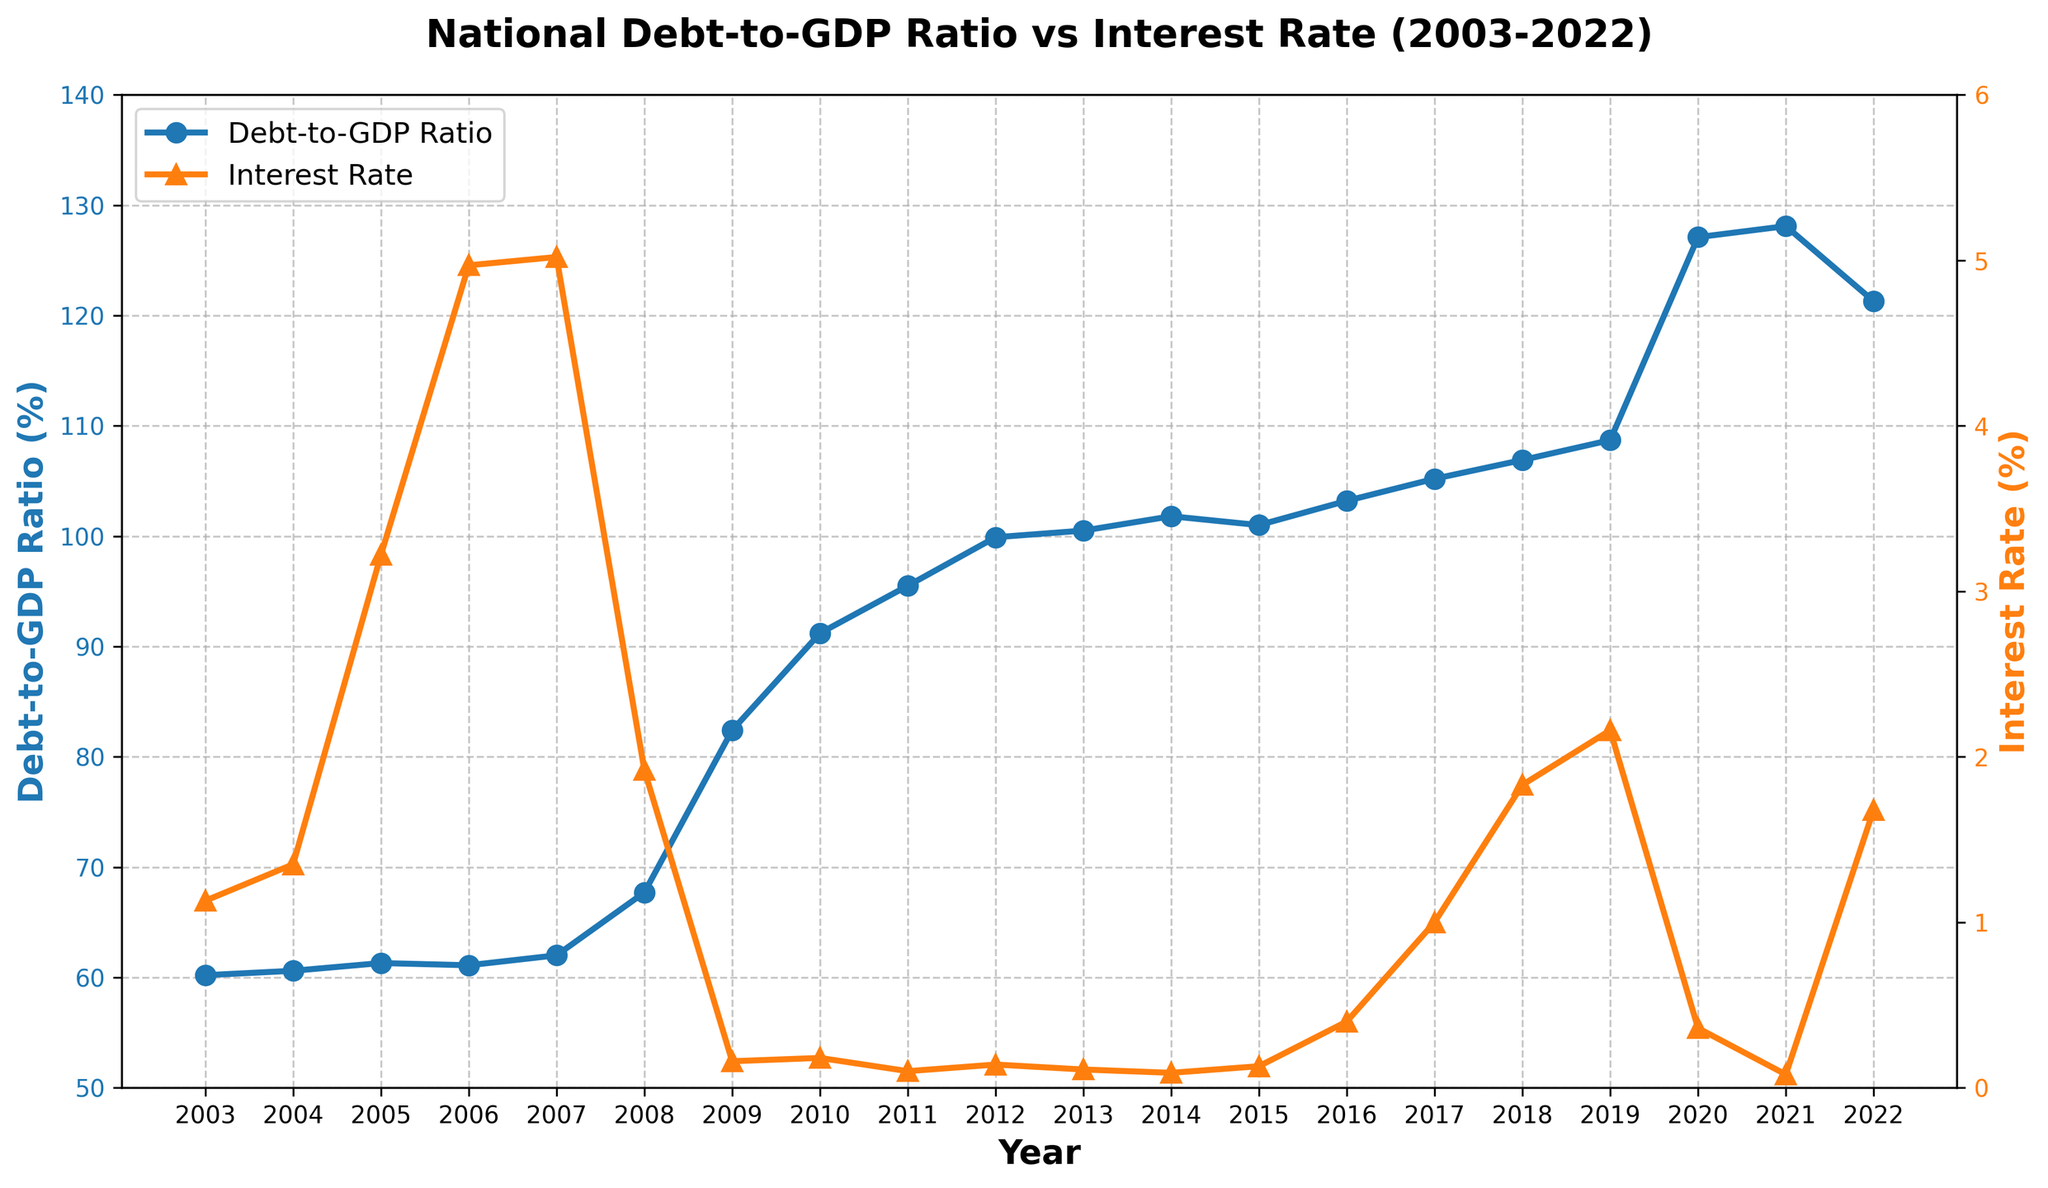What trend do we observe in the Debt-to-GDP Ratio between 2008 and 2011? To determine the trend, look at the plot line for the Debt-to-GDP Ratio during these years. In 2008, the ratio is 67.7%, and it increases to 95.5% in 2011. This shows a clear upward trend.
Answer: Upward trend What was the Interest Rate in 2013, and how does it compare to the Interest Rate in 2021? Look at the Interest Rate markers on the graph for 2013 and 2021. The rate in 2013 is approximately 0.11%, and in 2021 it is around 0.08%. Comparing these values, the Interest Rate in 2021 is slightly lower.
Answer: Lower in 2021 When did the National Debt-to-GDP Ratio reach its peak, and what was its value? To find the peak, identify the highest point on the Debt-to-GDP Ratio line. The ratio reaches its peak in 2021 at 128.1%.
Answer: 2021, 128.1% How did the Interest Rate change from 2008 to 2009? Observe the Interest Rate values for 2008 and 2009 on the graph. In 2008, the rate is approximately 1.92%, and in 2009 it drops significantly to around 0.16%. This indicates a sharp decline.
Answer: Sharp decline What was the Debt-to-GDP Ratio in 2020, and how does it compare to the previous year, 2019? Locate the Debt-to-GDP Ratio values for 2019 and 2020 on the graph. In 2019, the ratio is approximately 108.7%, and it increases significantly to 127.1% in 2020.
Answer: Higher in 2020 What is the average Interest Rate over the last 5 years shown in the plot? Compute the average for the Interest Rates from 2018 to 2022. Sum the rates: 1.83% (2018) + 2.16% (2019) + 0.36% (2020) + 0.08% (2021) + 1.68% (2022) = 6.11%. Divide by 5: 6.11% / 5 = 1.222%.
Answer: 1.222% How did the Interest Rate evolve during the financial crisis period of 2008-2009? Examine the Interest Rate line for 2008 and 2009. During this period, the rate drops dramatically from 1.92% in 2008 to 0.16% in 2009, indicating a sharp decrease during the financial crisis.
Answer: Sharp decrease Which year experienced the steepest increase in the Debt-to-GDP Ratio? Identify the year-to-year changes in the Debt-to-GDP Ratio. The steepest increase is observed between 2019 (108.7%) and 2020 (127.1%), with a change of 18.4%.
Answer: 2019-2020 